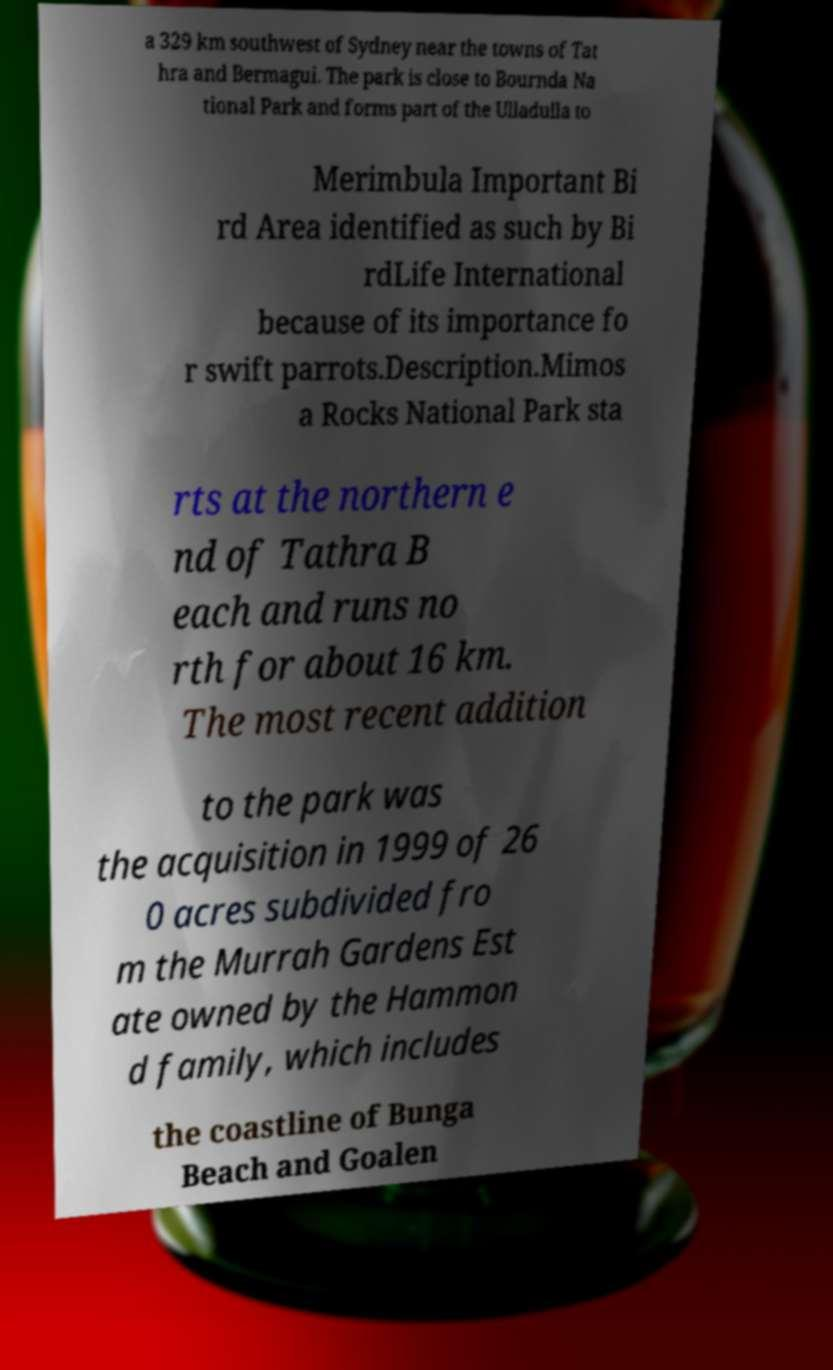I need the written content from this picture converted into text. Can you do that? a 329 km southwest of Sydney near the towns of Tat hra and Bermagui. The park is close to Bournda Na tional Park and forms part of the Ulladulla to Merimbula Important Bi rd Area identified as such by Bi rdLife International because of its importance fo r swift parrots.Description.Mimos a Rocks National Park sta rts at the northern e nd of Tathra B each and runs no rth for about 16 km. The most recent addition to the park was the acquisition in 1999 of 26 0 acres subdivided fro m the Murrah Gardens Est ate owned by the Hammon d family, which includes the coastline of Bunga Beach and Goalen 